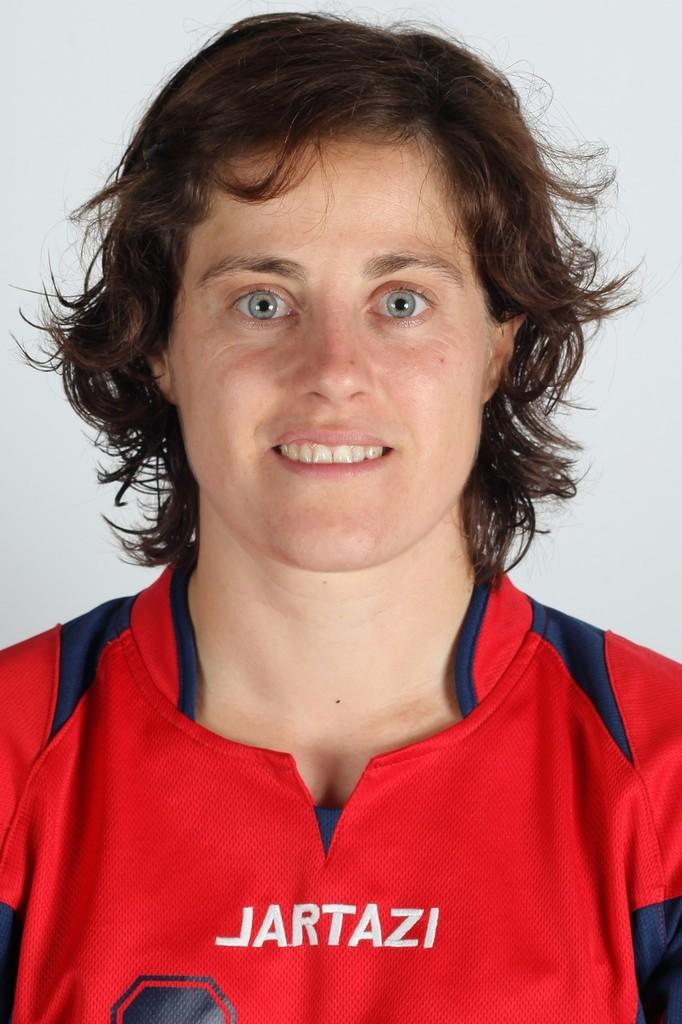<image>
Create a compact narrative representing the image presented. A player with a red Jartazi jersey poses for the camera. 